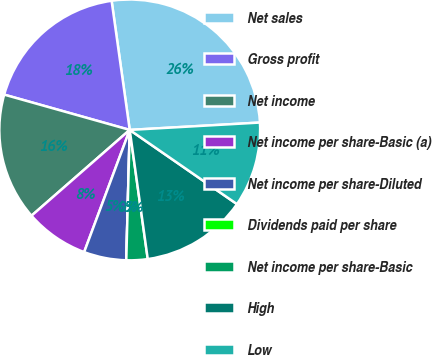Convert chart. <chart><loc_0><loc_0><loc_500><loc_500><pie_chart><fcel>Net sales<fcel>Gross profit<fcel>Net income<fcel>Net income per share-Basic (a)<fcel>Net income per share-Diluted<fcel>Dividends paid per share<fcel>Net income per share-Basic<fcel>High<fcel>Low<nl><fcel>26.32%<fcel>18.42%<fcel>15.79%<fcel>7.89%<fcel>5.26%<fcel>0.0%<fcel>2.63%<fcel>13.16%<fcel>10.53%<nl></chart> 